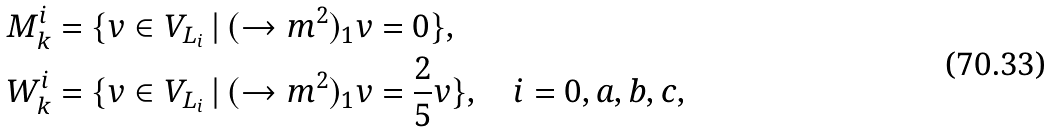<formula> <loc_0><loc_0><loc_500><loc_500>M _ { k } ^ { i } & = \{ v \in V _ { L _ { i } } \, | \, ( \to m ^ { 2 } ) _ { 1 } v = 0 \} , \\ W _ { k } ^ { i } & = \{ v \in V _ { L _ { i } } \, | \, ( \to m ^ { 2 } ) _ { 1 } v = \frac { 2 } { 5 } v \} , \quad i = 0 , a , b , c ,</formula> 